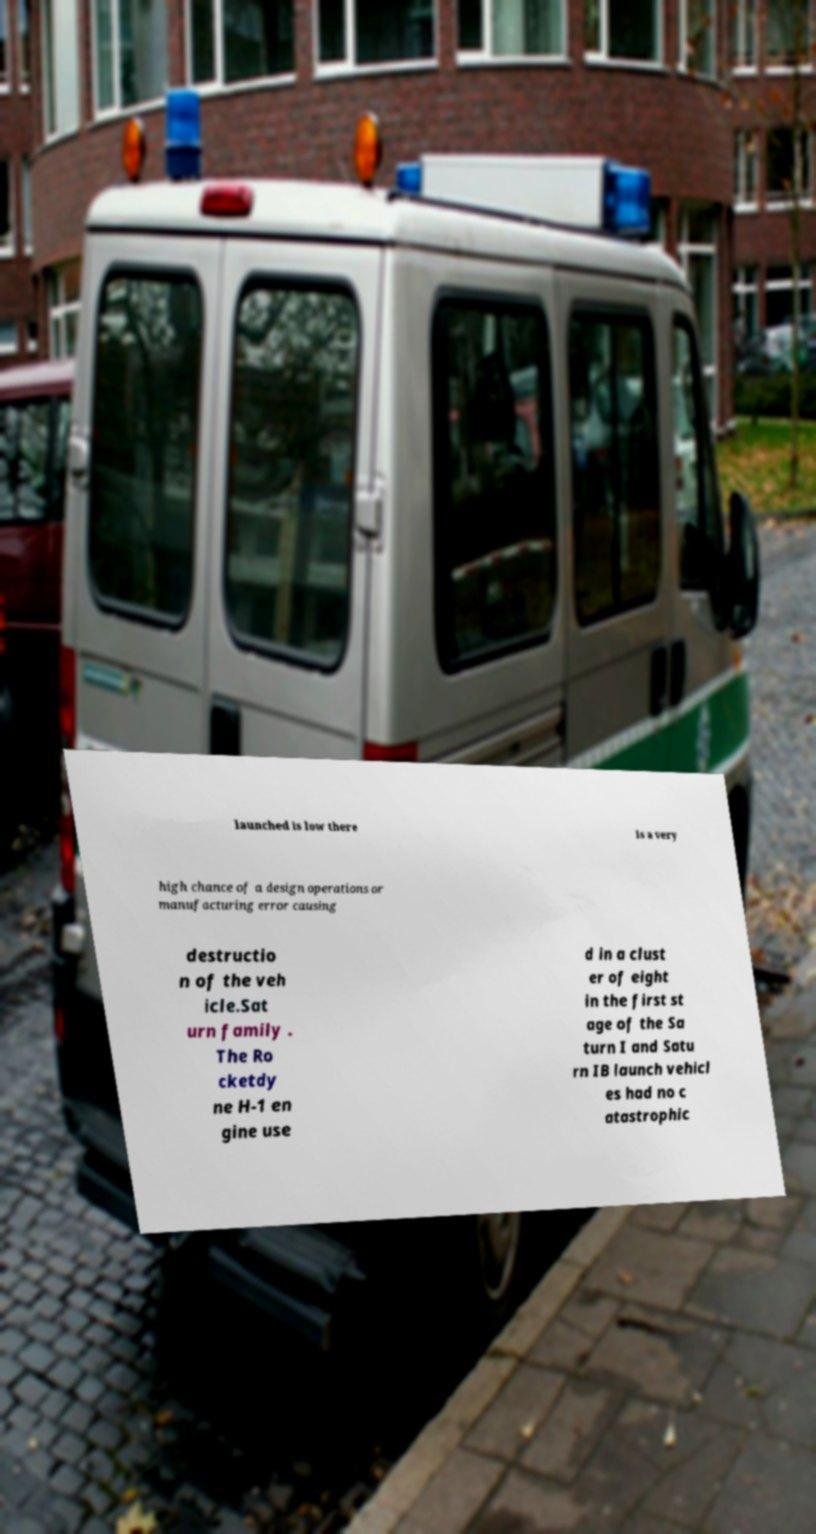Can you accurately transcribe the text from the provided image for me? launched is low there is a very high chance of a design operations or manufacturing error causing destructio n of the veh icle.Sat urn family . The Ro cketdy ne H-1 en gine use d in a clust er of eight in the first st age of the Sa turn I and Satu rn IB launch vehicl es had no c atastrophic 